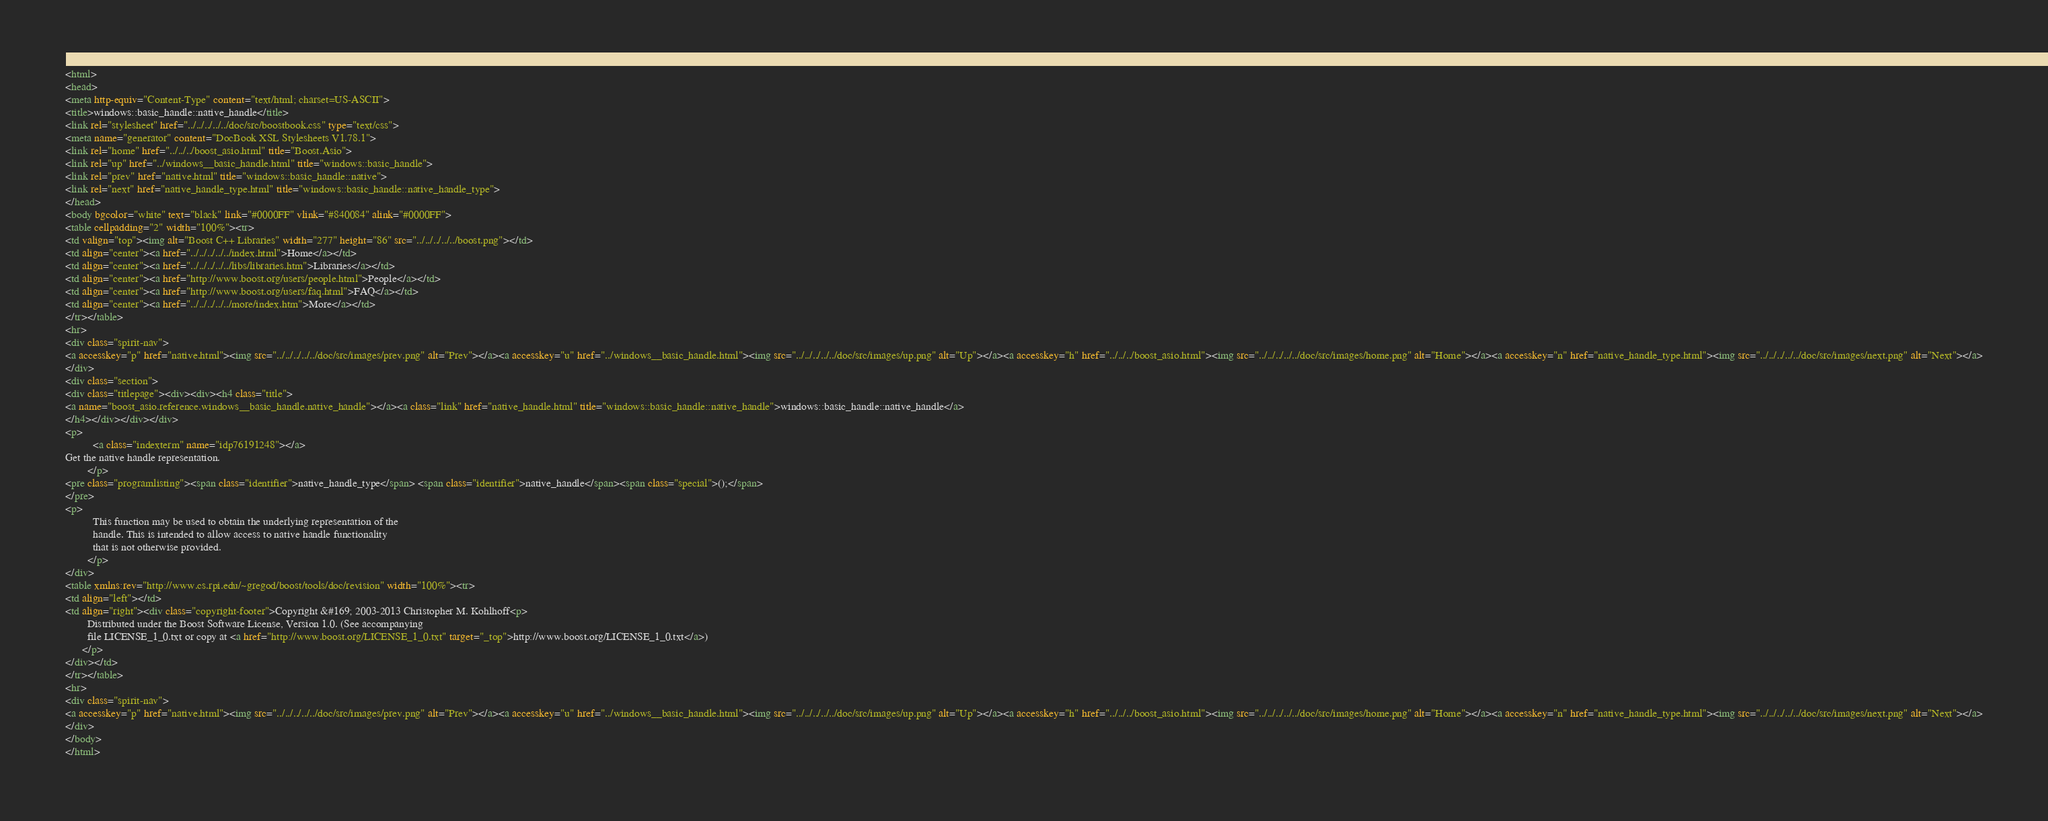Convert code to text. <code><loc_0><loc_0><loc_500><loc_500><_HTML_><html>
<head>
<meta http-equiv="Content-Type" content="text/html; charset=US-ASCII">
<title>windows::basic_handle::native_handle</title>
<link rel="stylesheet" href="../../../../../doc/src/boostbook.css" type="text/css">
<meta name="generator" content="DocBook XSL Stylesheets V1.78.1">
<link rel="home" href="../../../boost_asio.html" title="Boost.Asio">
<link rel="up" href="../windows__basic_handle.html" title="windows::basic_handle">
<link rel="prev" href="native.html" title="windows::basic_handle::native">
<link rel="next" href="native_handle_type.html" title="windows::basic_handle::native_handle_type">
</head>
<body bgcolor="white" text="black" link="#0000FF" vlink="#840084" alink="#0000FF">
<table cellpadding="2" width="100%"><tr>
<td valign="top"><img alt="Boost C++ Libraries" width="277" height="86" src="../../../../../boost.png"></td>
<td align="center"><a href="../../../../../index.html">Home</a></td>
<td align="center"><a href="../../../../../libs/libraries.htm">Libraries</a></td>
<td align="center"><a href="http://www.boost.org/users/people.html">People</a></td>
<td align="center"><a href="http://www.boost.org/users/faq.html">FAQ</a></td>
<td align="center"><a href="../../../../../more/index.htm">More</a></td>
</tr></table>
<hr>
<div class="spirit-nav">
<a accesskey="p" href="native.html"><img src="../../../../../doc/src/images/prev.png" alt="Prev"></a><a accesskey="u" href="../windows__basic_handle.html"><img src="../../../../../doc/src/images/up.png" alt="Up"></a><a accesskey="h" href="../../../boost_asio.html"><img src="../../../../../doc/src/images/home.png" alt="Home"></a><a accesskey="n" href="native_handle_type.html"><img src="../../../../../doc/src/images/next.png" alt="Next"></a>
</div>
<div class="section">
<div class="titlepage"><div><div><h4 class="title">
<a name="boost_asio.reference.windows__basic_handle.native_handle"></a><a class="link" href="native_handle.html" title="windows::basic_handle::native_handle">windows::basic_handle::native_handle</a>
</h4></div></div></div>
<p>
          <a class="indexterm" name="idp76191248"></a> 
Get the native handle representation.
        </p>
<pre class="programlisting"><span class="identifier">native_handle_type</span> <span class="identifier">native_handle</span><span class="special">();</span>
</pre>
<p>
          This function may be used to obtain the underlying representation of the
          handle. This is intended to allow access to native handle functionality
          that is not otherwise provided.
        </p>
</div>
<table xmlns:rev="http://www.cs.rpi.edu/~gregod/boost/tools/doc/revision" width="100%"><tr>
<td align="left"></td>
<td align="right"><div class="copyright-footer">Copyright &#169; 2003-2013 Christopher M. Kohlhoff<p>
        Distributed under the Boost Software License, Version 1.0. (See accompanying
        file LICENSE_1_0.txt or copy at <a href="http://www.boost.org/LICENSE_1_0.txt" target="_top">http://www.boost.org/LICENSE_1_0.txt</a>)
      </p>
</div></td>
</tr></table>
<hr>
<div class="spirit-nav">
<a accesskey="p" href="native.html"><img src="../../../../../doc/src/images/prev.png" alt="Prev"></a><a accesskey="u" href="../windows__basic_handle.html"><img src="../../../../../doc/src/images/up.png" alt="Up"></a><a accesskey="h" href="../../../boost_asio.html"><img src="../../../../../doc/src/images/home.png" alt="Home"></a><a accesskey="n" href="native_handle_type.html"><img src="../../../../../doc/src/images/next.png" alt="Next"></a>
</div>
</body>
</html>
</code> 